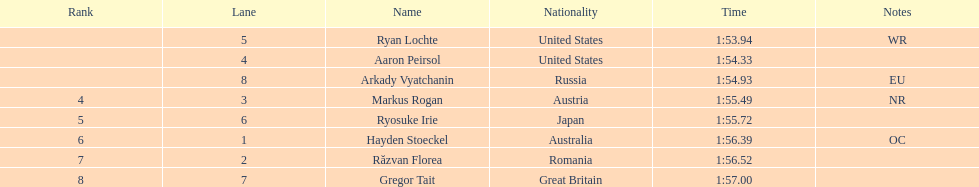Can you identify the swimmers? Ryan Lochte, Aaron Peirsol, Arkady Vyatchanin, Markus Rogan, Ryosuke Irie, Hayden Stoeckel, Răzvan Florea, Gregor Tait. How long did it take for ryosuke irie to complete his swim? 1:55.72. 